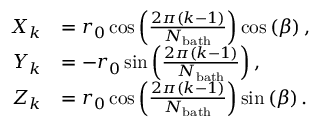<formula> <loc_0><loc_0><loc_500><loc_500>\begin{array} { r l } { X _ { k } } & { = r _ { 0 } \cos \left ( \frac { 2 \pi ( k - 1 ) } { N _ { b a t h } } \right ) \cos \left ( \beta \right ) , } \\ { Y _ { k } } & { = - r _ { 0 } \sin \left ( \frac { 2 \pi ( k - 1 ) } { N _ { b a t h } } \right ) , } \\ { Z _ { k } } & { = r _ { 0 } \cos \left ( \frac { 2 \pi ( k - 1 ) } { N _ { b a t h } } \right ) \sin \left ( \beta \right ) . } \end{array}</formula> 